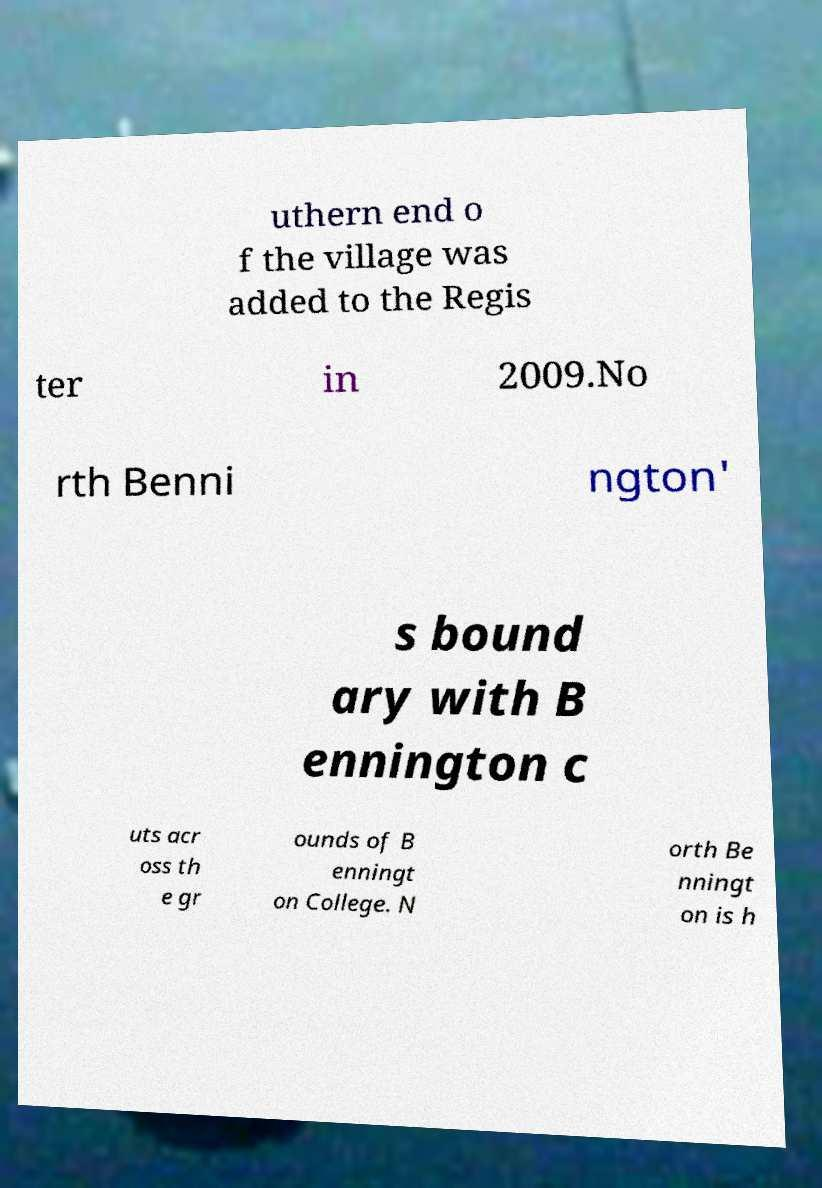Please identify and transcribe the text found in this image. uthern end o f the village was added to the Regis ter in 2009.No rth Benni ngton' s bound ary with B ennington c uts acr oss th e gr ounds of B enningt on College. N orth Be nningt on is h 